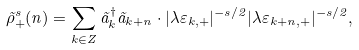<formula> <loc_0><loc_0><loc_500><loc_500>\tilde { \rho } _ { + } ^ { s } ( n ) = \sum _ { k \in Z } \tilde { a } _ { k } ^ { \dagger } \tilde { a } _ { k + n } \cdot | \lambda \varepsilon _ { k , + } | ^ { - s / 2 } | \lambda \varepsilon _ { k + n , + } | ^ { - s / 2 } ,</formula> 